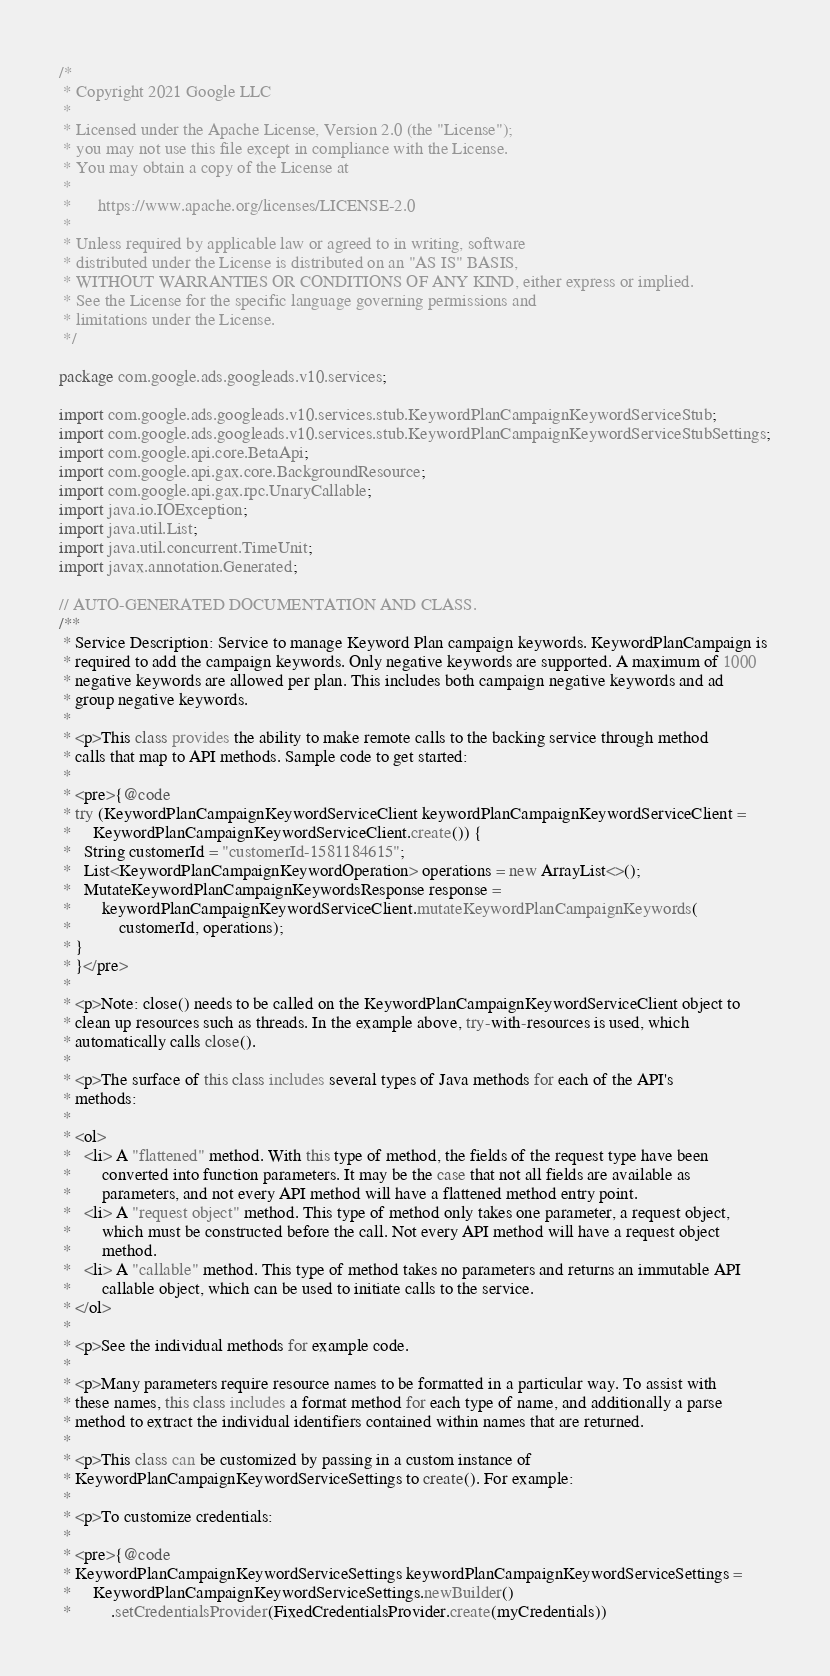<code> <loc_0><loc_0><loc_500><loc_500><_Java_>/*
 * Copyright 2021 Google LLC
 *
 * Licensed under the Apache License, Version 2.0 (the "License");
 * you may not use this file except in compliance with the License.
 * You may obtain a copy of the License at
 *
 *      https://www.apache.org/licenses/LICENSE-2.0
 *
 * Unless required by applicable law or agreed to in writing, software
 * distributed under the License is distributed on an "AS IS" BASIS,
 * WITHOUT WARRANTIES OR CONDITIONS OF ANY KIND, either express or implied.
 * See the License for the specific language governing permissions and
 * limitations under the License.
 */

package com.google.ads.googleads.v10.services;

import com.google.ads.googleads.v10.services.stub.KeywordPlanCampaignKeywordServiceStub;
import com.google.ads.googleads.v10.services.stub.KeywordPlanCampaignKeywordServiceStubSettings;
import com.google.api.core.BetaApi;
import com.google.api.gax.core.BackgroundResource;
import com.google.api.gax.rpc.UnaryCallable;
import java.io.IOException;
import java.util.List;
import java.util.concurrent.TimeUnit;
import javax.annotation.Generated;

// AUTO-GENERATED DOCUMENTATION AND CLASS.
/**
 * Service Description: Service to manage Keyword Plan campaign keywords. KeywordPlanCampaign is
 * required to add the campaign keywords. Only negative keywords are supported. A maximum of 1000
 * negative keywords are allowed per plan. This includes both campaign negative keywords and ad
 * group negative keywords.
 *
 * <p>This class provides the ability to make remote calls to the backing service through method
 * calls that map to API methods. Sample code to get started:
 *
 * <pre>{@code
 * try (KeywordPlanCampaignKeywordServiceClient keywordPlanCampaignKeywordServiceClient =
 *     KeywordPlanCampaignKeywordServiceClient.create()) {
 *   String customerId = "customerId-1581184615";
 *   List<KeywordPlanCampaignKeywordOperation> operations = new ArrayList<>();
 *   MutateKeywordPlanCampaignKeywordsResponse response =
 *       keywordPlanCampaignKeywordServiceClient.mutateKeywordPlanCampaignKeywords(
 *           customerId, operations);
 * }
 * }</pre>
 *
 * <p>Note: close() needs to be called on the KeywordPlanCampaignKeywordServiceClient object to
 * clean up resources such as threads. In the example above, try-with-resources is used, which
 * automatically calls close().
 *
 * <p>The surface of this class includes several types of Java methods for each of the API's
 * methods:
 *
 * <ol>
 *   <li> A "flattened" method. With this type of method, the fields of the request type have been
 *       converted into function parameters. It may be the case that not all fields are available as
 *       parameters, and not every API method will have a flattened method entry point.
 *   <li> A "request object" method. This type of method only takes one parameter, a request object,
 *       which must be constructed before the call. Not every API method will have a request object
 *       method.
 *   <li> A "callable" method. This type of method takes no parameters and returns an immutable API
 *       callable object, which can be used to initiate calls to the service.
 * </ol>
 *
 * <p>See the individual methods for example code.
 *
 * <p>Many parameters require resource names to be formatted in a particular way. To assist with
 * these names, this class includes a format method for each type of name, and additionally a parse
 * method to extract the individual identifiers contained within names that are returned.
 *
 * <p>This class can be customized by passing in a custom instance of
 * KeywordPlanCampaignKeywordServiceSettings to create(). For example:
 *
 * <p>To customize credentials:
 *
 * <pre>{@code
 * KeywordPlanCampaignKeywordServiceSettings keywordPlanCampaignKeywordServiceSettings =
 *     KeywordPlanCampaignKeywordServiceSettings.newBuilder()
 *         .setCredentialsProvider(FixedCredentialsProvider.create(myCredentials))</code> 